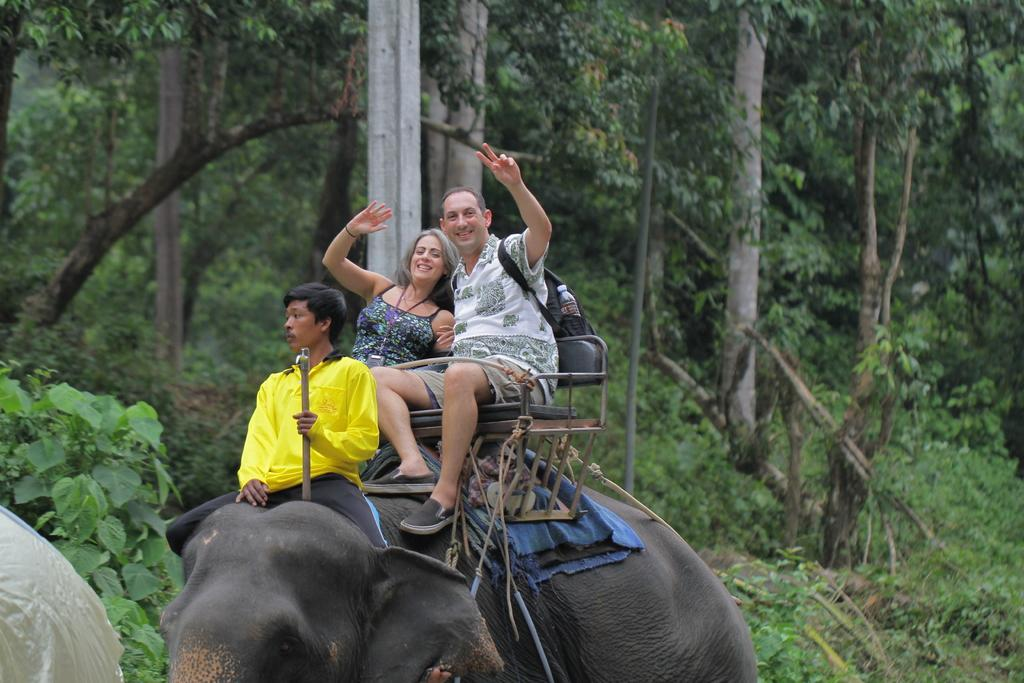How many people are on the elephant in the image? There are three members sitting on an elephant in the image. What can be seen in the background of the image? There are trees visible in the background of the image. Is there a beggar asking for money in the image? There is no beggar present in the image. What holiday is being celebrated in the image? There is no indication of a holiday being celebrated in the image. 